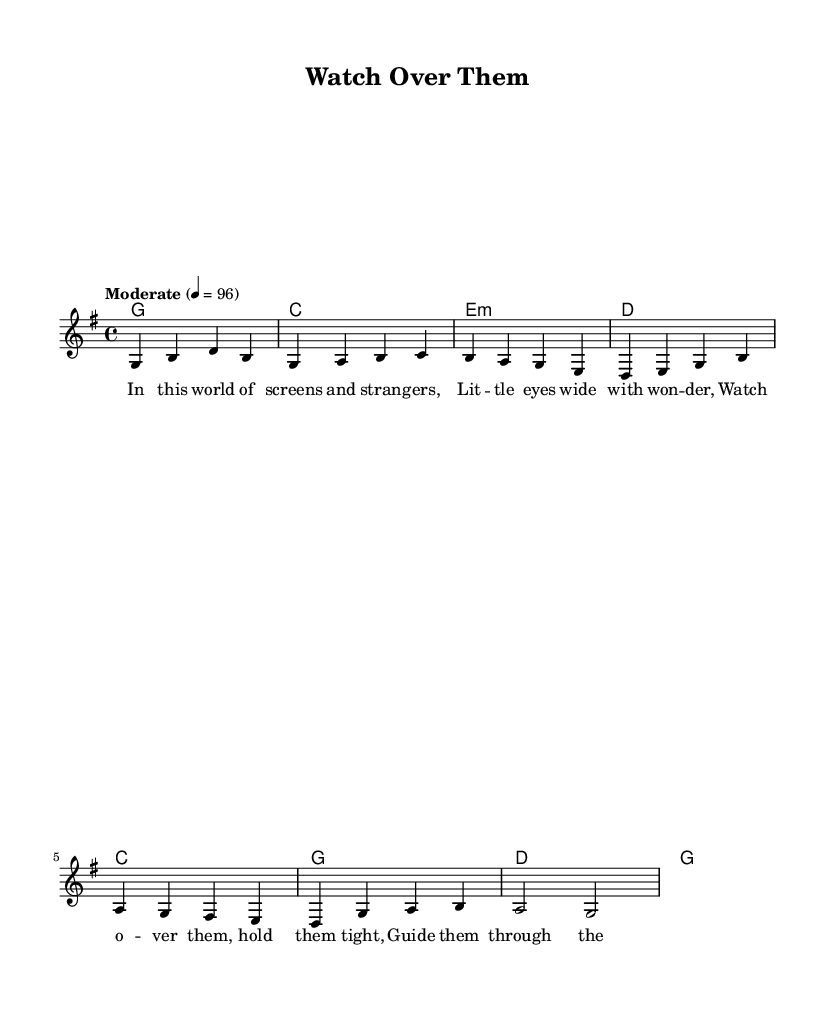What is the key signature of this music? The key signature is G major, which has one sharp (F#).
Answer: G major What is the time signature of this piece? The time signature is 4/4, indicating that there are four beats per measure and the quarter note gets one beat.
Answer: 4/4 What is the tempo indication for this sheet music? The tempo is marked as "Moderate," with a metronome marking of 96 beats per minute.
Answer: Moderate How many measures are in the verse section? The verse section consists of four measures, as seen in the chord progression provided.
Answer: Four What chords are used in the chorus? The chords used in the chorus are C, G, D, G, as indicated in the chord mode section for the chorus.
Answer: C, G, D, G What is the main theme of the lyrics as suggested by the title? The title "Watch Over Them" suggests a theme of parental care and concern for children's safety in a modern world.
Answer: Parental care and concern Which notes are played in the first measure of the melody? The first measure of the melody consists of the notes G, B, D, and B, which are all quarter notes.
Answer: G, B, D, B 